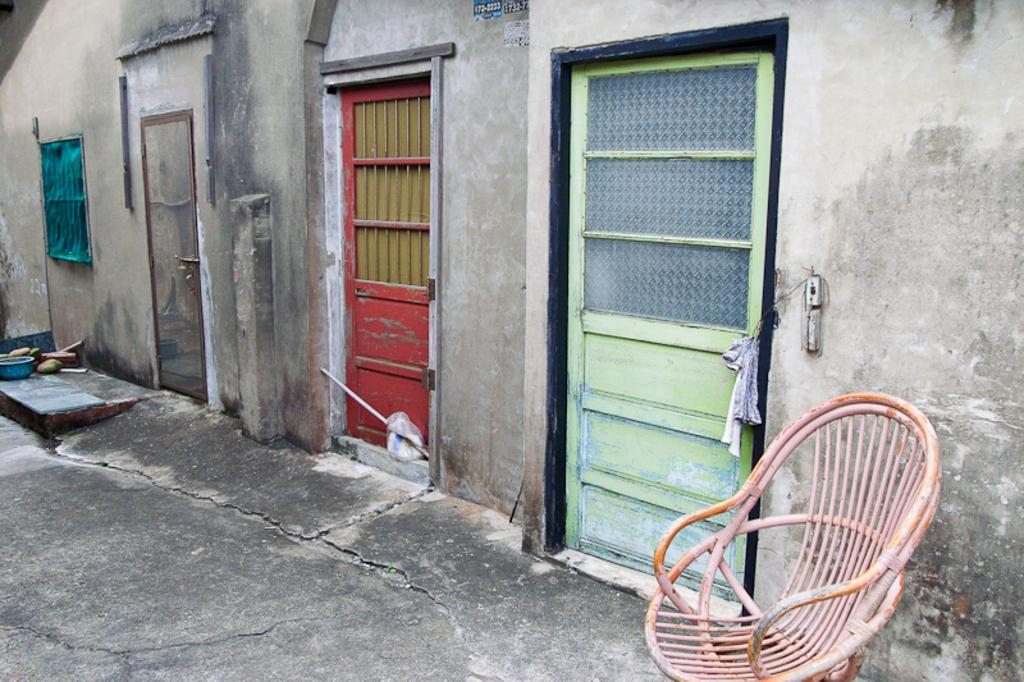What is placed on the floor in the image? There is a chair on the floor in the image. What can be seen on the left side of the image? There is a tub on the left side of the image. What else is on the floor in the image? There are objects on the floor in the image. What is visible in the background of the image? There is a wall with doors and a window in the background of the image. What type of whip is being used in the argument in the image? There is no whip or argument present in the image. How many doors are visible on the wall in the image? The provided facts do not specify the number of doors on the wall in the image. 